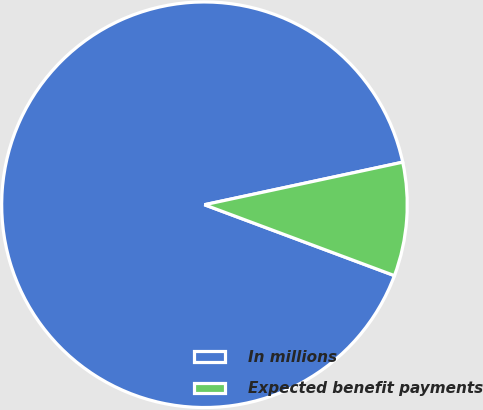<chart> <loc_0><loc_0><loc_500><loc_500><pie_chart><fcel>In millions<fcel>Expected benefit payments<nl><fcel>90.95%<fcel>9.05%<nl></chart> 